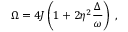Convert formula to latex. <formula><loc_0><loc_0><loc_500><loc_500>\Omega = 4 J \left ( 1 + 2 \eta ^ { 2 } \frac { \Delta } { \omega } \right ) \, ,</formula> 